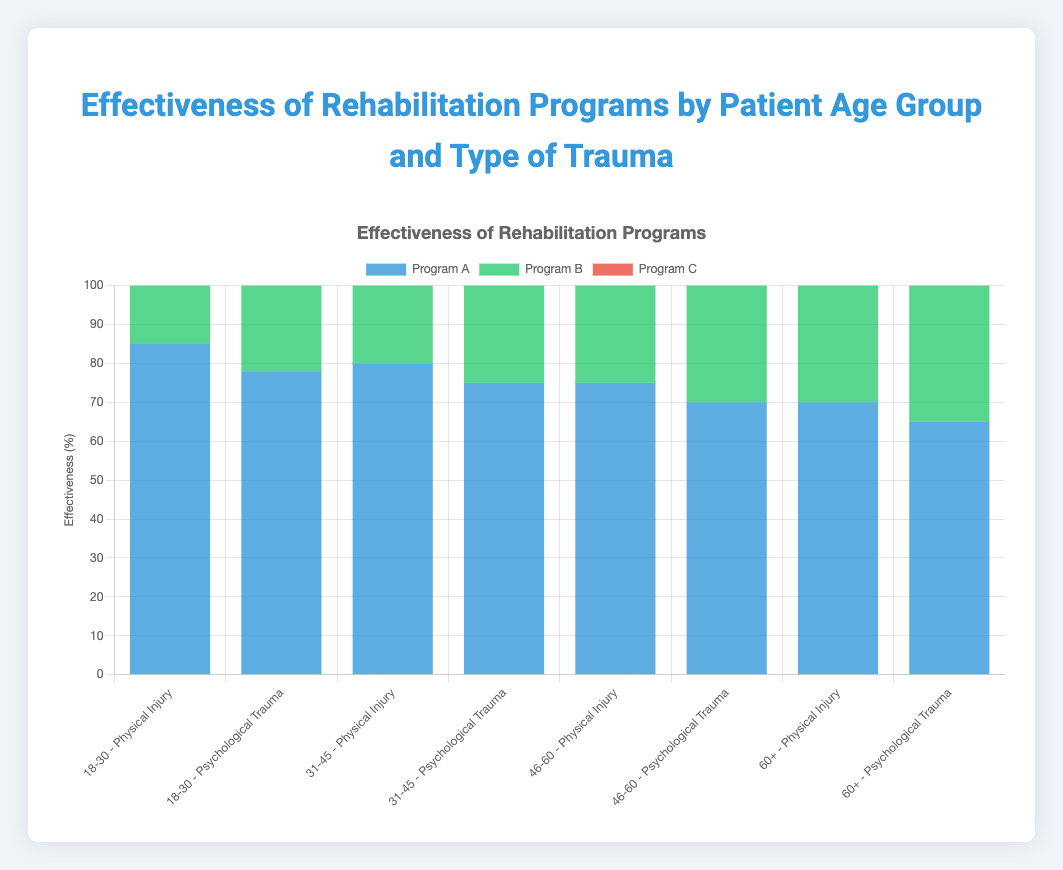What's the effectiveness of Program B for the age group 31-45 with Psychological Trauma? First, locate the age group 31-45 with Psychological Trauma in the figure. Then, check the bar corresponding to Program B. The value is 78%.
Answer: 78% Which program is more effective for the age group 18-30 with Psychological Trauma, Program A or Program C? Identify the age group 18-30 with Psychological Trauma in the figure. Compare the effectiveness of Program A (78%) with Program C (82%). Program C is more effective.
Answer: Program C What is the difference in effectiveness between Program A and Program B for the age group 46-60 with Physical Injury? Find the age group 46-60 with Physical Injury in the figure. Subtract the effectiveness of Program A (75%) from Program B (78%) to find the difference.
Answer: 3% Which age group shows the highest effectiveness for Program C across all trauma types? Look at the Program C bars for all age groups and trauma types. Identify the highest value, which is 82% for the age group 18-30 with Psychological Trauma.
Answer: 18-30 with Psychological Trauma What is the total effectiveness of all programs for the age group 60+ with Psychological Trauma? Locate the age group 60+ with Psychological Trauma in the figure. Add the effectiveness values of Program A (65%), Program B (62%), and Program C (60%). The total is 65 + 62 + 60 = 187%.
Answer: 187% Compare the effectiveness of Program A between the age groups 18-30 and 60+ with Physical Injury. Check the bars for Program A in the age groups 18-30 (85%) and 60+ (70%) with Physical Injury. Program A is more effective for the age group 18-30.
Answer: 18-30 Which program shows the least effectiveness for the age group 46-60 with Psychological Trauma? For the age group 46-60 with Psychological Trauma, look at the values for Programs A (70%), B (65%), and C (68%). Program B has the least effectiveness.
Answer: Program B What is the average effectiveness of Program C for Psychological Trauma across all age groups? Look at the effectiveness of Program C for Psychological Trauma in all age groups: 18-30 (82%), 31-45 (77%), 46-60 (68%), and 60+ (60%). Calculate the average: (82 + 77 + 68 + 60) / 4 = 71.75%.
Answer: 71.75% Which trauma type has higher average effectiveness for Program B in the age group 31-45? For the age group 31-45, compare the effectiveness of Program B for Physical Injury (85%) and Psychological Trauma (78%). Physical Injury has a higher average effectiveness.
Answer: Physical Injury How much higher is the effectiveness of Program B than Program C for the age group 18-30 with Physical Injury? Determine the effectiveness of Program B (90%) and Program C (80%) for the age group 18-30 with Physical Injury. Subtract the two values: 90% - 80% = 10%.
Answer: 10% 